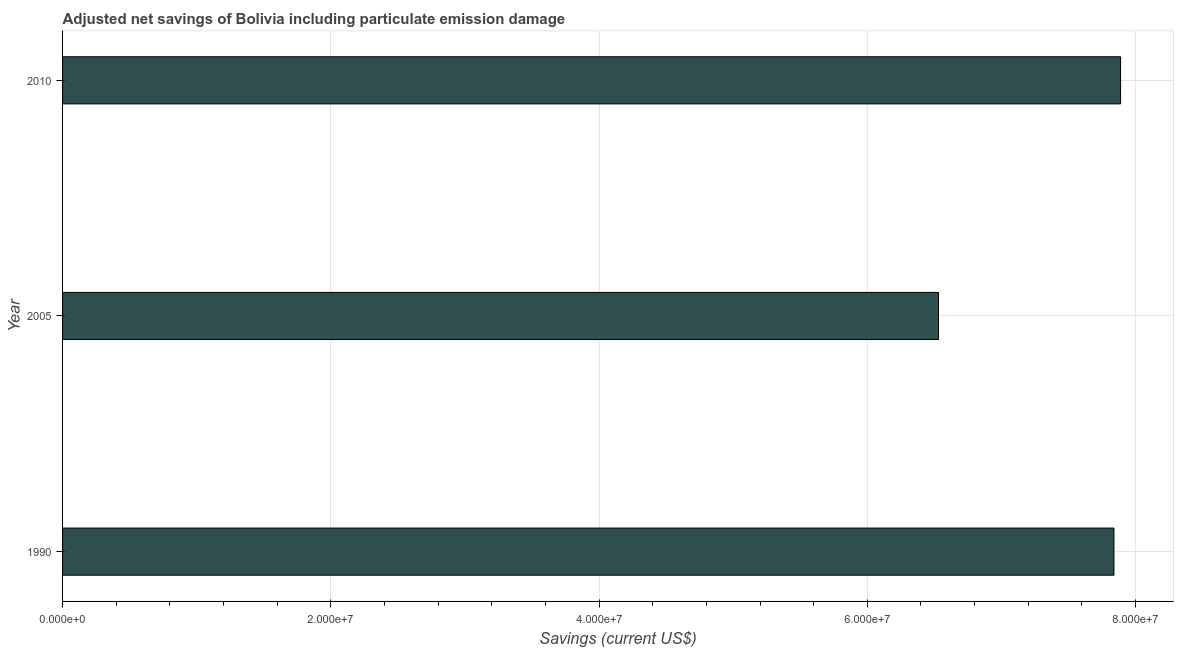Does the graph contain any zero values?
Give a very brief answer. No. Does the graph contain grids?
Give a very brief answer. Yes. What is the title of the graph?
Make the answer very short. Adjusted net savings of Bolivia including particulate emission damage. What is the label or title of the X-axis?
Provide a succinct answer. Savings (current US$). What is the adjusted net savings in 2005?
Your answer should be very brief. 6.53e+07. Across all years, what is the maximum adjusted net savings?
Keep it short and to the point. 7.89e+07. Across all years, what is the minimum adjusted net savings?
Give a very brief answer. 6.53e+07. In which year was the adjusted net savings maximum?
Offer a very short reply. 2010. What is the sum of the adjusted net savings?
Provide a short and direct response. 2.23e+08. What is the difference between the adjusted net savings in 2005 and 2010?
Your answer should be compact. -1.36e+07. What is the average adjusted net savings per year?
Keep it short and to the point. 7.42e+07. What is the median adjusted net savings?
Ensure brevity in your answer.  7.84e+07. In how many years, is the adjusted net savings greater than 16000000 US$?
Keep it short and to the point. 3. What is the difference between the highest and the second highest adjusted net savings?
Your answer should be compact. 4.93e+05. What is the difference between the highest and the lowest adjusted net savings?
Offer a very short reply. 1.36e+07. In how many years, is the adjusted net savings greater than the average adjusted net savings taken over all years?
Keep it short and to the point. 2. How many bars are there?
Offer a very short reply. 3. Are all the bars in the graph horizontal?
Ensure brevity in your answer.  Yes. How many years are there in the graph?
Your response must be concise. 3. What is the difference between two consecutive major ticks on the X-axis?
Offer a terse response. 2.00e+07. Are the values on the major ticks of X-axis written in scientific E-notation?
Your answer should be compact. Yes. What is the Savings (current US$) of 1990?
Your response must be concise. 7.84e+07. What is the Savings (current US$) of 2005?
Provide a succinct answer. 6.53e+07. What is the Savings (current US$) in 2010?
Provide a short and direct response. 7.89e+07. What is the difference between the Savings (current US$) in 1990 and 2005?
Keep it short and to the point. 1.31e+07. What is the difference between the Savings (current US$) in 1990 and 2010?
Offer a terse response. -4.93e+05. What is the difference between the Savings (current US$) in 2005 and 2010?
Give a very brief answer. -1.36e+07. What is the ratio of the Savings (current US$) in 2005 to that in 2010?
Your answer should be compact. 0.83. 